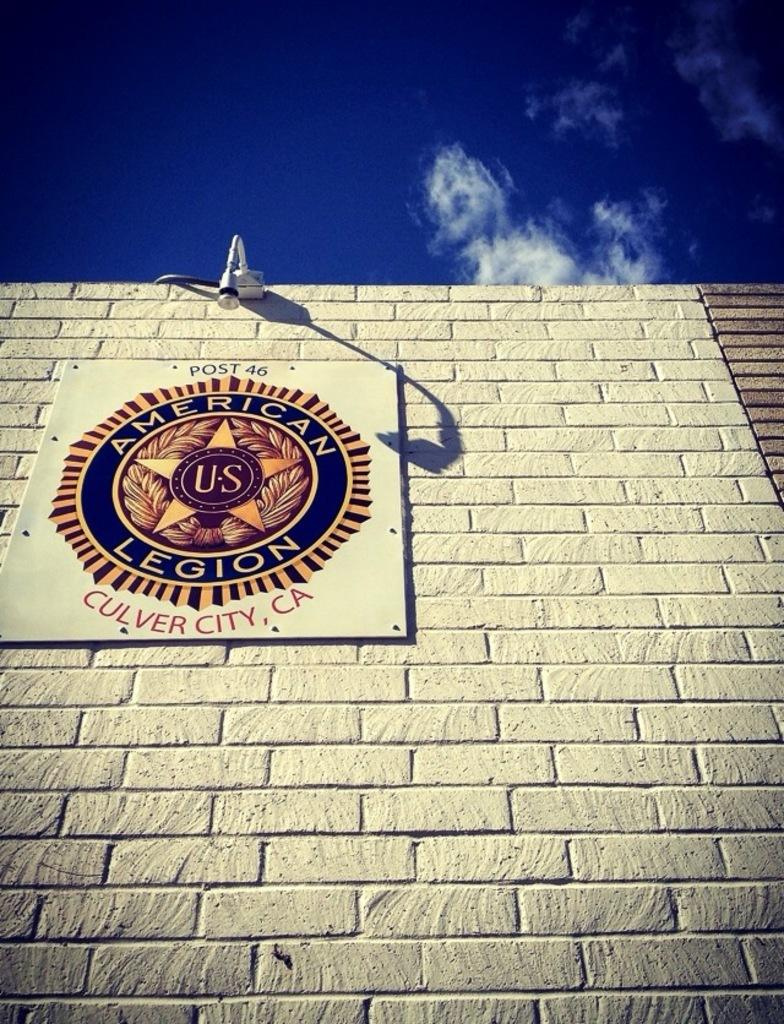What is the main structure visible in the image? There is a wall in the image. What is attached to the wall? There is a notice board attached to the wall. What can be seen at the top of the image? The sky is visible at the top of the image. Can you tell me how many squirrels are climbing on the wall in the image? There are no squirrels visible in the image; it only features a wall and a notice board. What book is the person reading on the wall in the image? There is no person or book present in the image; it only features a wall and a notice board. 